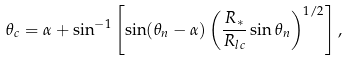<formula> <loc_0><loc_0><loc_500><loc_500>\theta _ { c } = \alpha + \sin ^ { - 1 } \left [ \sin ( \theta _ { n } - \alpha ) \left ( \frac { R _ { * } } { R _ { l c } } \sin \theta _ { n } \right ) ^ { 1 / 2 } \right ] ,</formula> 